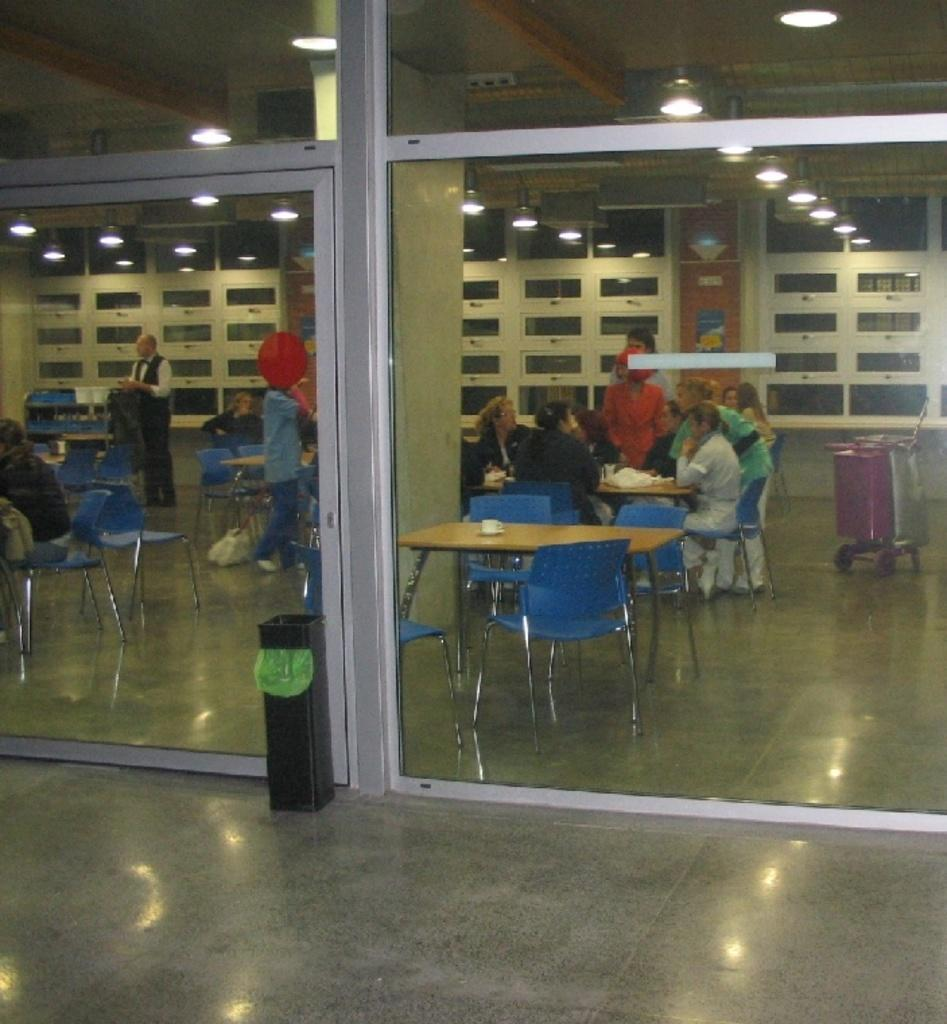What are the people in the image doing? There is a group of people sitting on chairs in the image. What can be seen on the table in front of the people? There is a cup on the table in the image. What type of door is visible in the scene? There is a glass door in front of the scene. What is located on the floor near the people? There is a bin on the floor in the image. What is the source of light visible at the top of the image? There is a light visible at the top of the image. What type of disease is affecting the sisters in the image? There are no sisters or any mention of a disease in the image. 